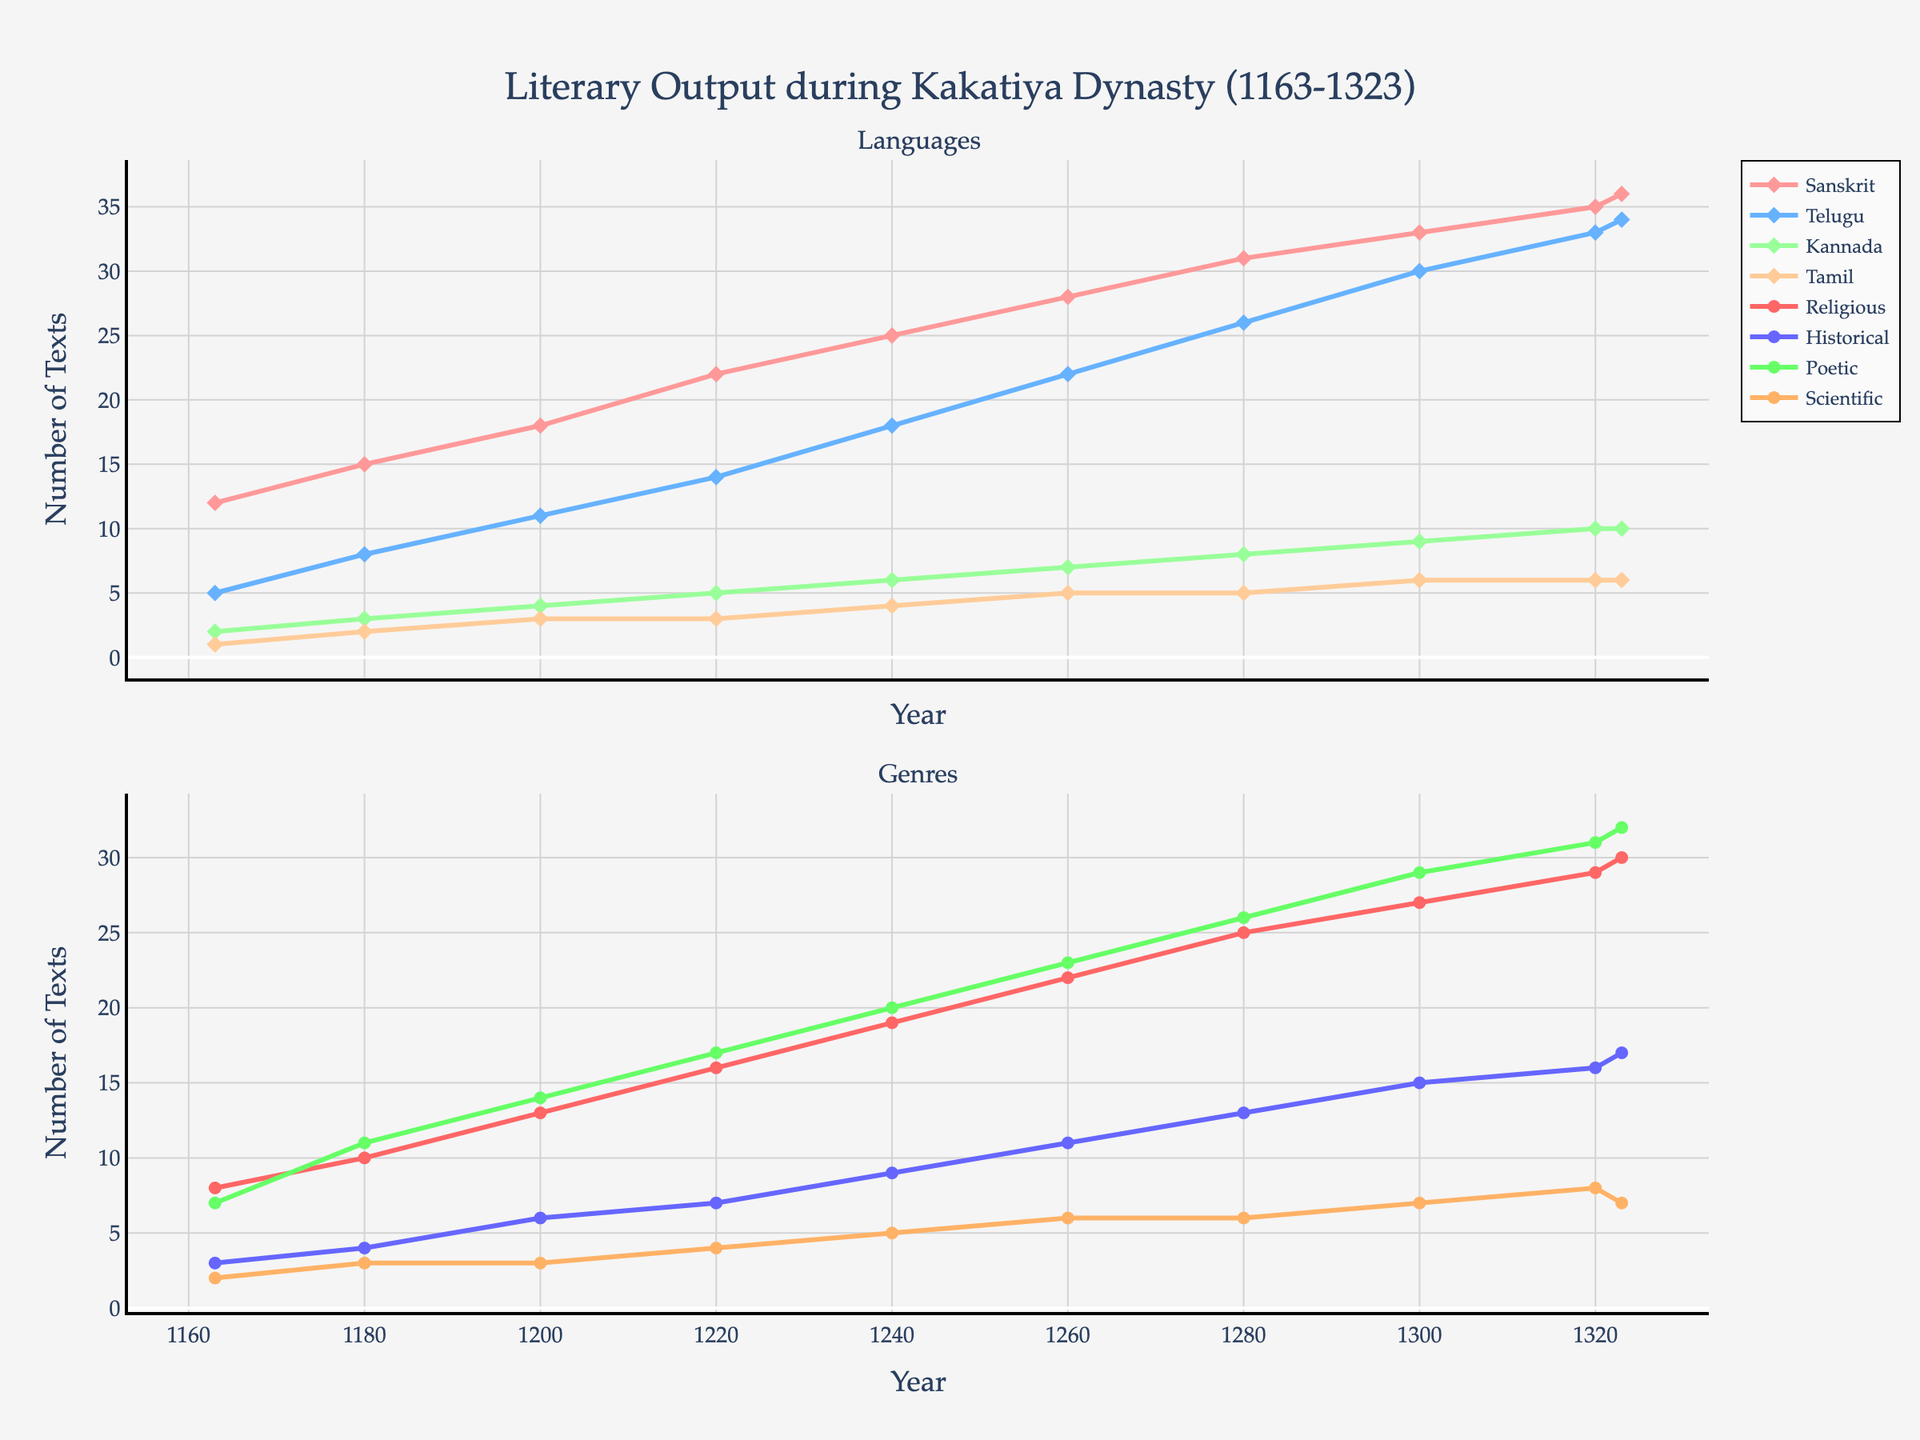What's the total number of Telugu and Sanskrit texts produced in 1300? At 1300, the number of Telugu texts is 30 and Sanskrit texts is 33. Summing these, we get 30 + 33 = 63.
Answer: 63 Which language saw the greatest increase in text production from 1163 to 1323? Comparing text production in 1163 and 1323, we see that Sanskrit increased from 12 to 36 (+24), Telugu from 5 to 34 (+29), Kannada from 2 to 10 (+8), and Tamil from 1 to 6 (+5). Telugu had the greatest increase with +29.
Answer: Telugu In which year did Poetic texts surpass Historical texts? Looking at the genres, Poetic texts surpass Historical texts starting in 1200 where Poetic texts are 14 and Historical texts are 6.
Answer: 1200 During which years did the production of Religious texts surpass 25? Religious text production surpasses 25 in the years 1280 with 25 texts, 1300 with 27 texts, and 1320 with 29 texts.
Answer: 1280, 1300, 1320 What was the maximum number of Scientific texts produced and in which years did this occur? The maximum number of Scientific texts produced is 8, occurring in the year 1320.
Answer: 8, 1320 Compare the trend of Tamil texts to Kannada texts over the years. Which maintained a more stable pattern? From 1163 to 1323, Tamil texts increase steadily from 1 to 6 with slight changes, while Kannada texts show more fluctuation, growing from 2 to 10 with larger jumps. Tamil maintained a more stable pattern.
Answer: Tamil What's the combined total number of texts produced across all languages and genres in 1260? Summing up all values for 1260: 28 (Sanskrit) + 22 (Telugu) + 7 (Kannada) + 5 (Tamil) + 22 (Religious) + 11 (Historical) + 23 (Poetic) + 6 (Scientific) = 124.
Answer: 124 In what year did Telugu text production first surpass that of Kannada and by how many texts? In 1180, Telugu texts (8) first surpass Kannada texts (3), and the difference is 8 - 3 = 5.
Answer: 1180, 5 What visual color represents Historical texts in the figure? Historical texts are represented in blue in the figure.
Answer: Blue 